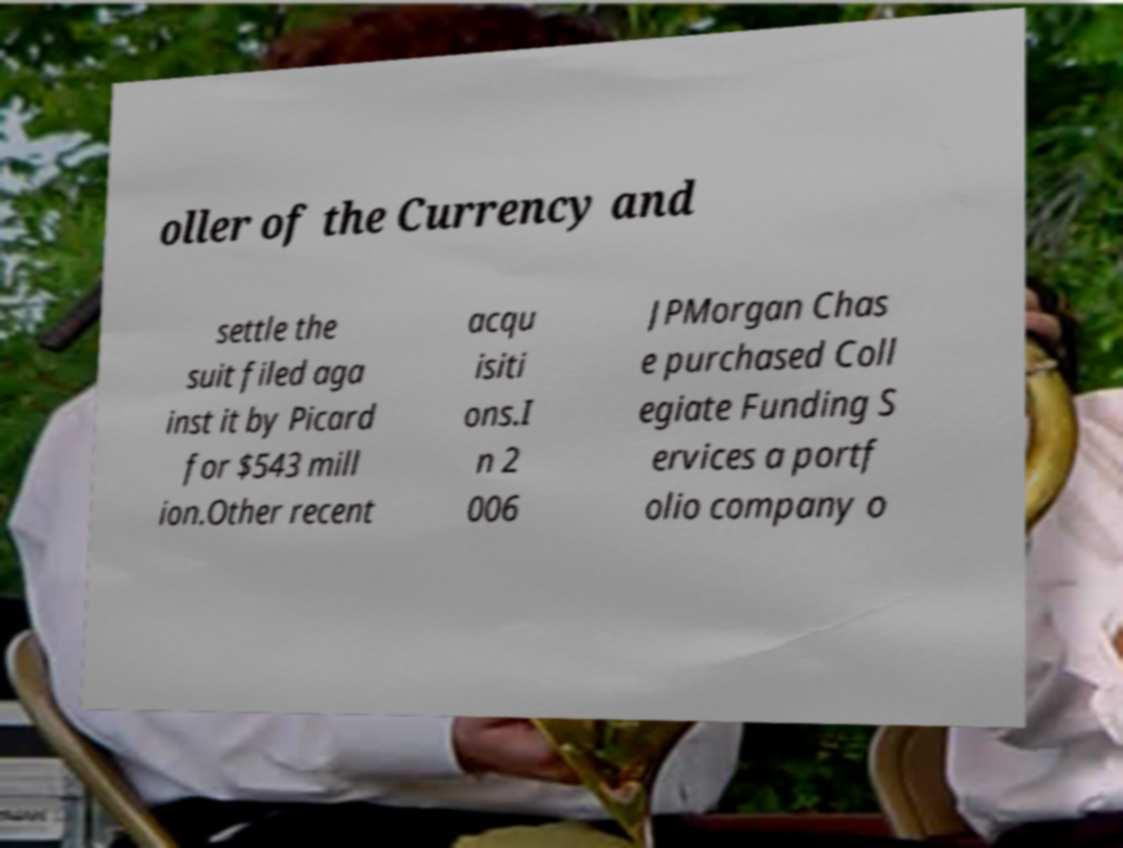I need the written content from this picture converted into text. Can you do that? oller of the Currency and settle the suit filed aga inst it by Picard for $543 mill ion.Other recent acqu isiti ons.I n 2 006 JPMorgan Chas e purchased Coll egiate Funding S ervices a portf olio company o 